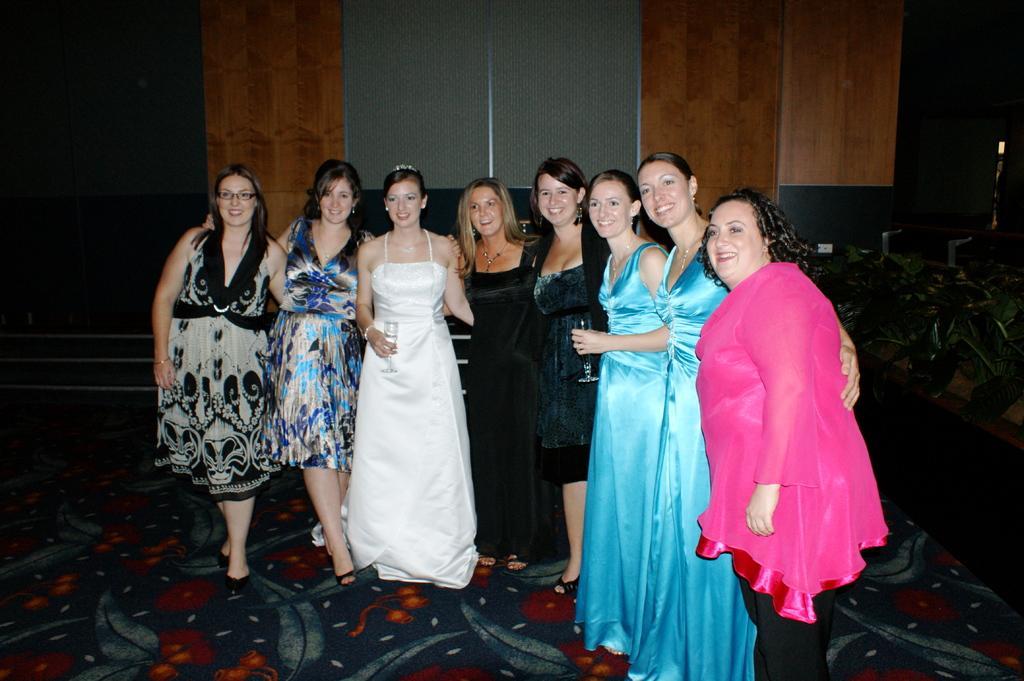Describe this image in one or two sentences. In this image we can see there are few people standing with a smile. In the background there is a wall. On the right side there are some plants. 